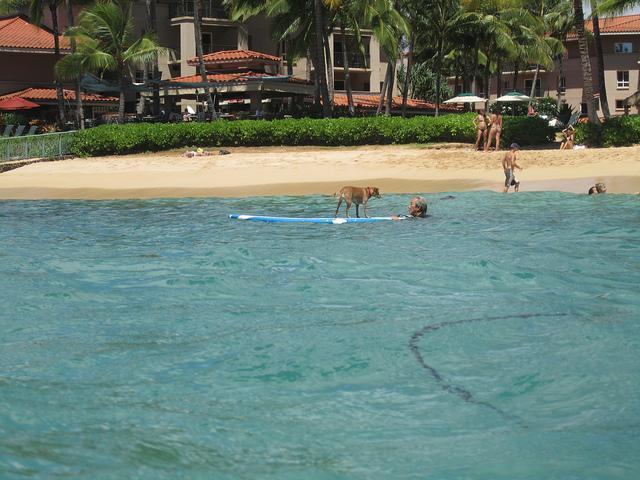What is preventing the dog from being submerged in the water?
Select the accurate response from the four choices given to answer the question.
Options: Surf board, owner, leash, collar. Surf board. 